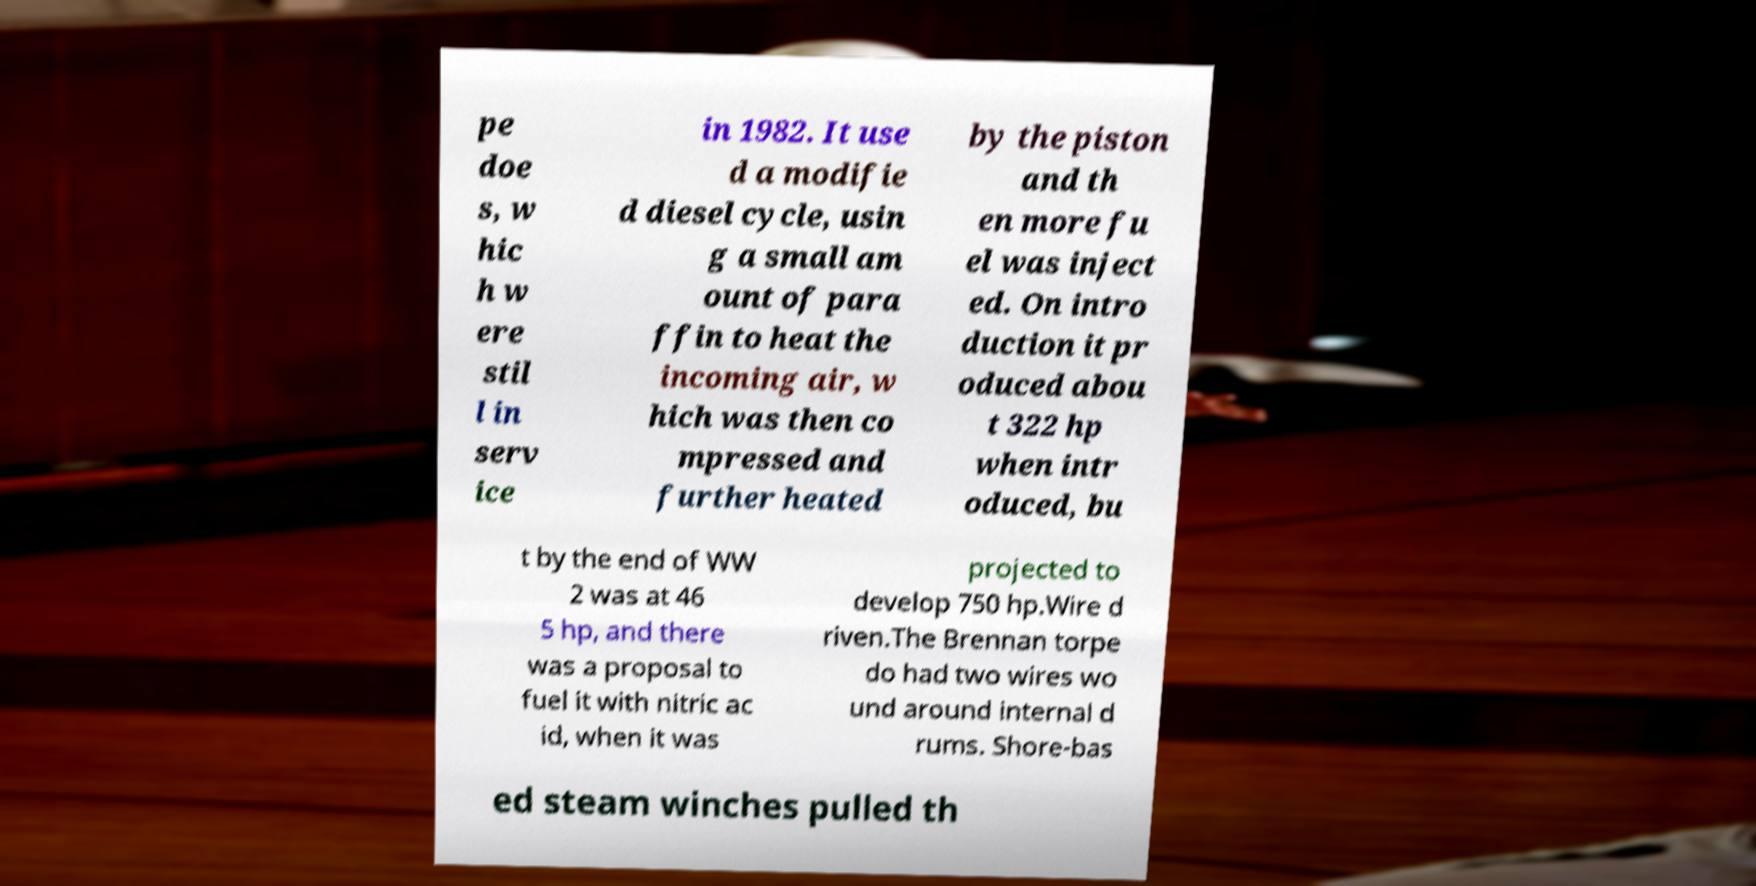For documentation purposes, I need the text within this image transcribed. Could you provide that? pe doe s, w hic h w ere stil l in serv ice in 1982. It use d a modifie d diesel cycle, usin g a small am ount of para ffin to heat the incoming air, w hich was then co mpressed and further heated by the piston and th en more fu el was inject ed. On intro duction it pr oduced abou t 322 hp when intr oduced, bu t by the end of WW 2 was at 46 5 hp, and there was a proposal to fuel it with nitric ac id, when it was projected to develop 750 hp.Wire d riven.The Brennan torpe do had two wires wo und around internal d rums. Shore-bas ed steam winches pulled th 